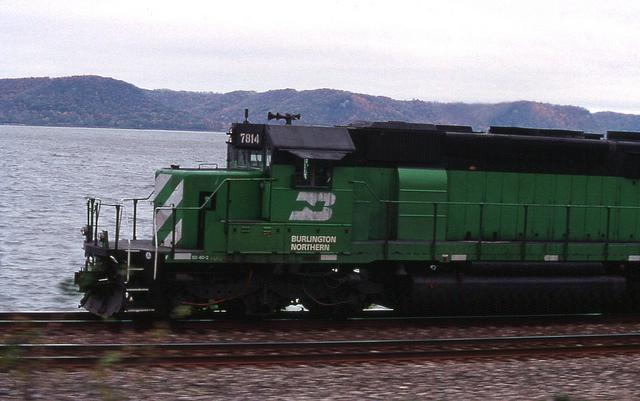What is the main color on the train?
Short answer required. Green. What color is the train?
Quick response, please. Green. What is the writing on the train?
Give a very brief answer. Burlington northern. What is behind the train?
Be succinct. Water. What railroad line does this train belong to?
Answer briefly. Burlington northern. What words are written on the train?
Quick response, please. Burlington northern. Can you see the train tracks?
Keep it brief. Yes. What country is this train from?
Quick response, please. Usa. 